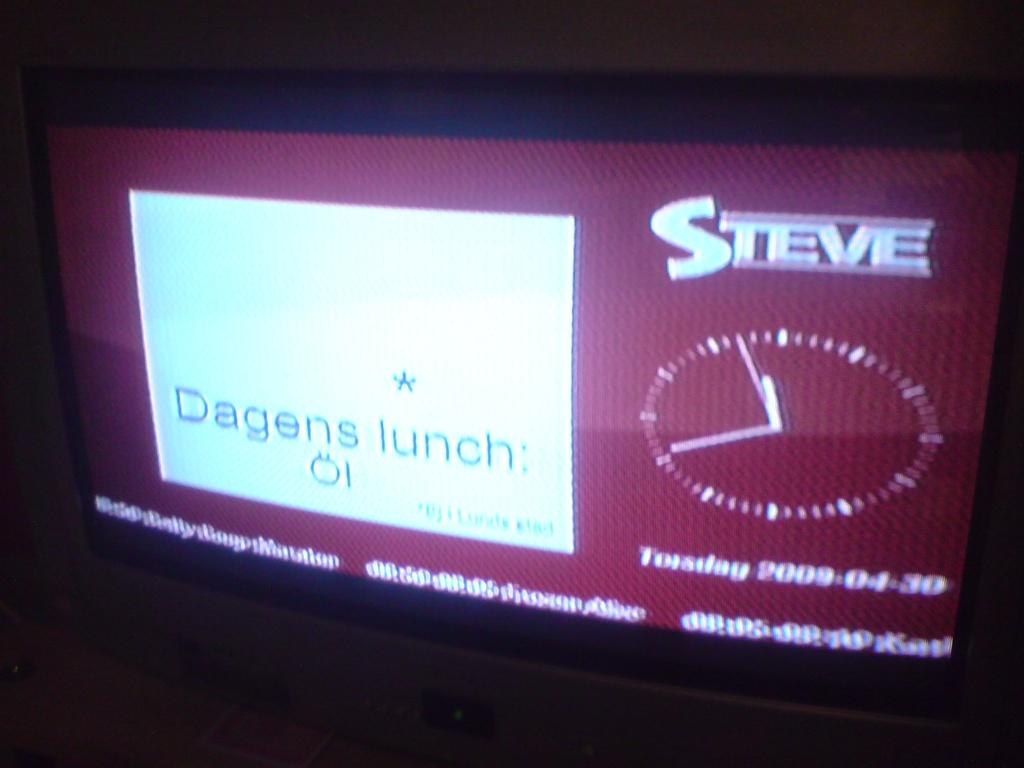What time is on the clock?
Your answer should be compact. 11:41. 